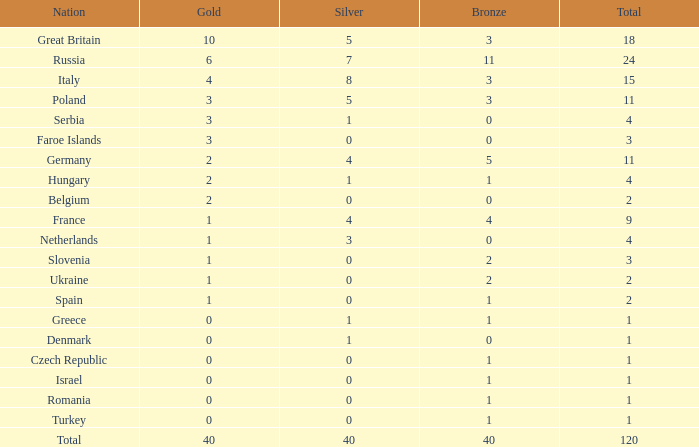What is Turkey's average Gold entry that also has a Bronze entry that is smaller than 2 and the Total is greater than 1? None. 